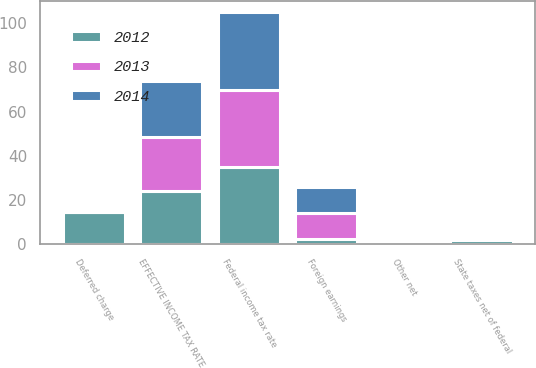<chart> <loc_0><loc_0><loc_500><loc_500><stacked_bar_chart><ecel><fcel>Federal income tax rate<fcel>State taxes net of federal<fcel>Foreign earnings<fcel>Deferred charge<fcel>Other net<fcel>EFFECTIVE INCOME TAX RATE<nl><fcel>2012<fcel>35<fcel>1.8<fcel>2.2<fcel>14.6<fcel>0.4<fcel>24<nl><fcel>2013<fcel>35<fcel>1.4<fcel>11.8<fcel>0<fcel>0.1<fcel>24.7<nl><fcel>2014<fcel>35<fcel>1.3<fcel>11.9<fcel>0<fcel>0.6<fcel>25<nl></chart> 